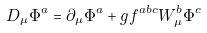<formula> <loc_0><loc_0><loc_500><loc_500>D _ { \mu } \Phi ^ { a } = \partial _ { \mu } \Phi ^ { a } + g f ^ { a b c } W _ { \mu } ^ { b } \Phi ^ { c }</formula> 